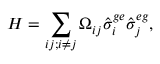Convert formula to latex. <formula><loc_0><loc_0><loc_500><loc_500>H = \sum _ { i j ; i \neq j } \Omega _ { i j } \hat { \sigma } _ { i } ^ { g e } \hat { \sigma } _ { j } ^ { e g } ,</formula> 